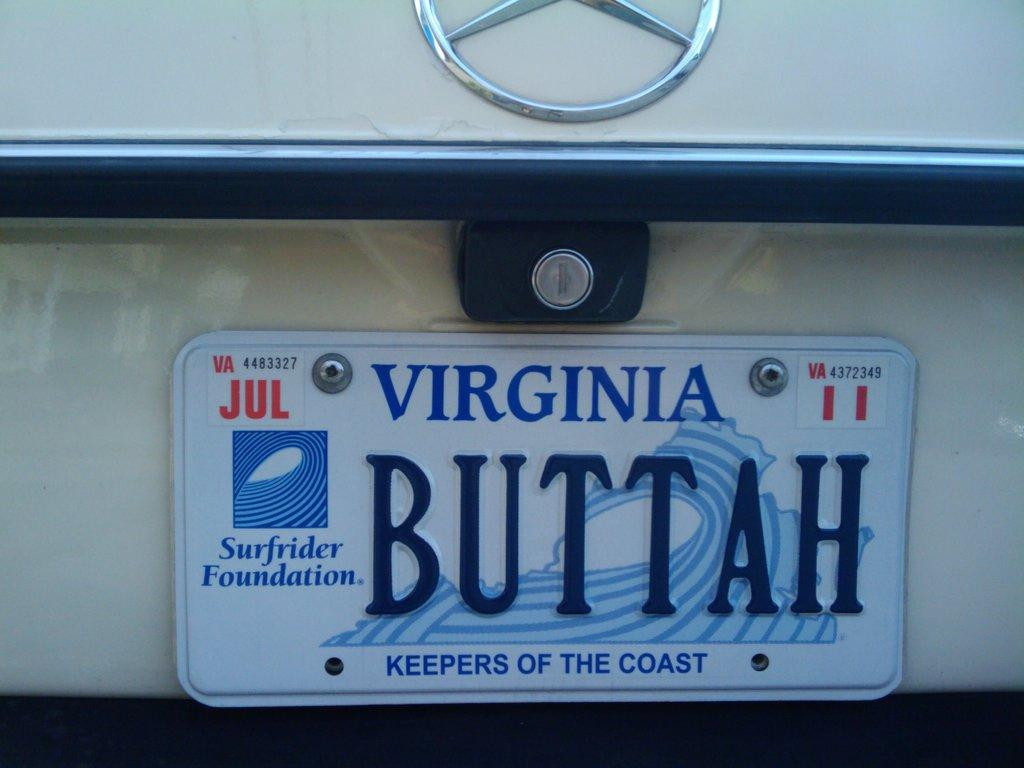What can be seen on the vehicle in the image? There is a number plate visible on the vehicle, and there is also a logo on the vehicle. Can you describe the number plate? Unfortunately, the details of the number plate cannot be determined from the image. What type of logo is present on the vehicle? The specifics of the logo cannot be determined from the image. How many friends are sitting on the leaf in the image? There is no leaf or friends present in the image. 